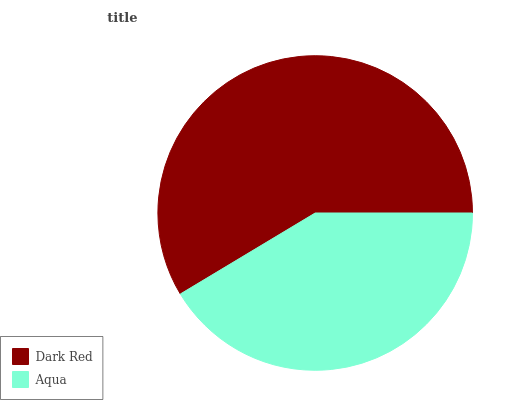Is Aqua the minimum?
Answer yes or no. Yes. Is Dark Red the maximum?
Answer yes or no. Yes. Is Aqua the maximum?
Answer yes or no. No. Is Dark Red greater than Aqua?
Answer yes or no. Yes. Is Aqua less than Dark Red?
Answer yes or no. Yes. Is Aqua greater than Dark Red?
Answer yes or no. No. Is Dark Red less than Aqua?
Answer yes or no. No. Is Dark Red the high median?
Answer yes or no. Yes. Is Aqua the low median?
Answer yes or no. Yes. Is Aqua the high median?
Answer yes or no. No. Is Dark Red the low median?
Answer yes or no. No. 